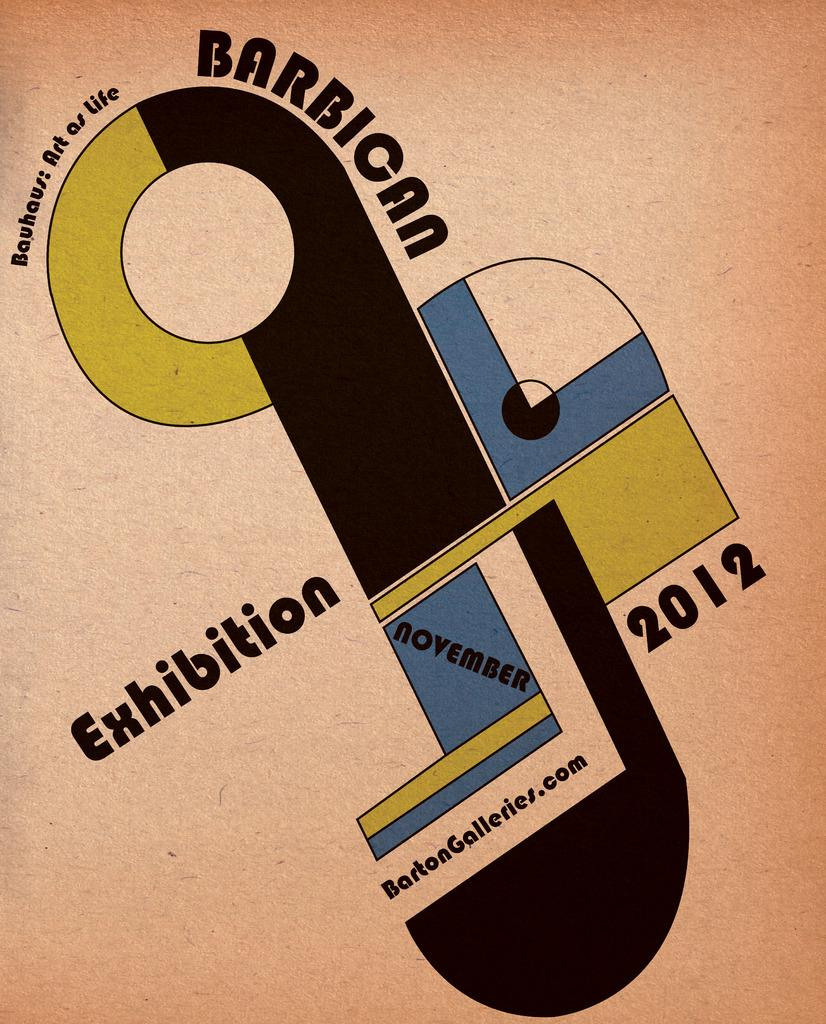<image>
Relay a brief, clear account of the picture shown. Poster showing Exhibition which takes place in November 2012. 